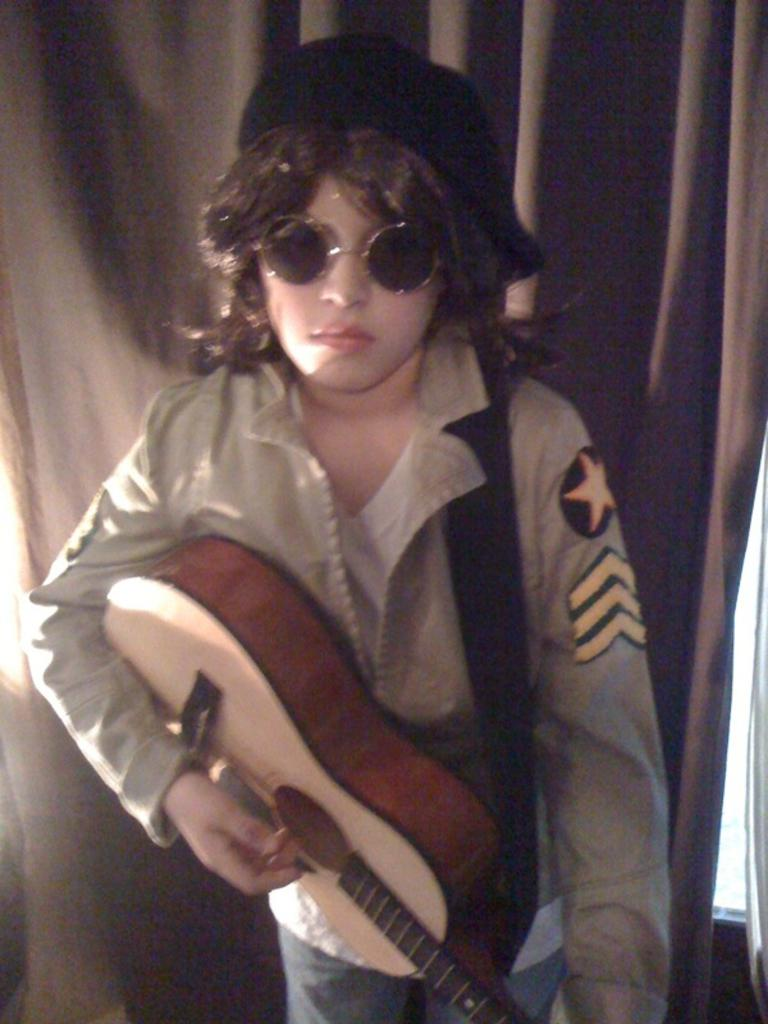What is the main subject of the image? There is a person in the image. What is the person doing in the image? The person is standing and playing a guitar. What type of ice can be seen melting on the guitar in the image? There is no ice present in the image, and the guitar is not melting. 